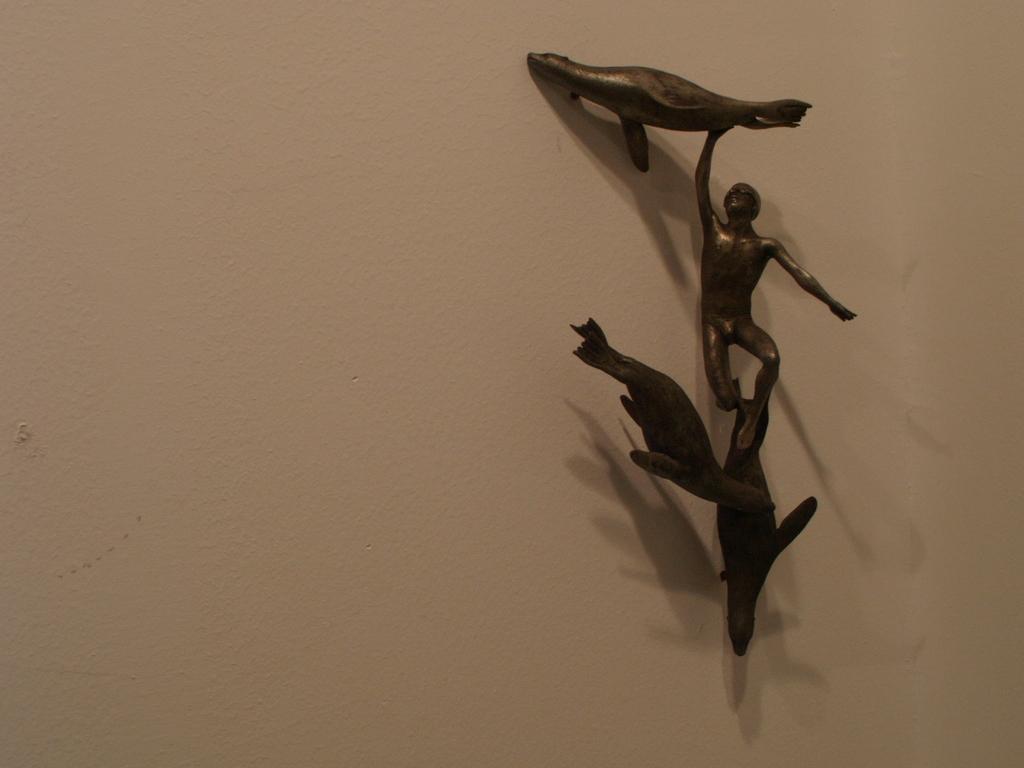Could you give a brief overview of what you see in this image? These are the statues made up of metal that are sticked to the wall. 